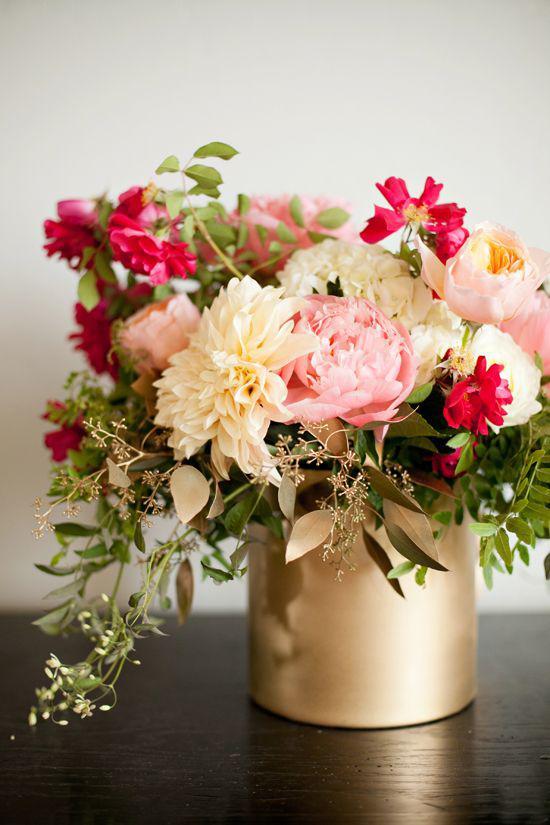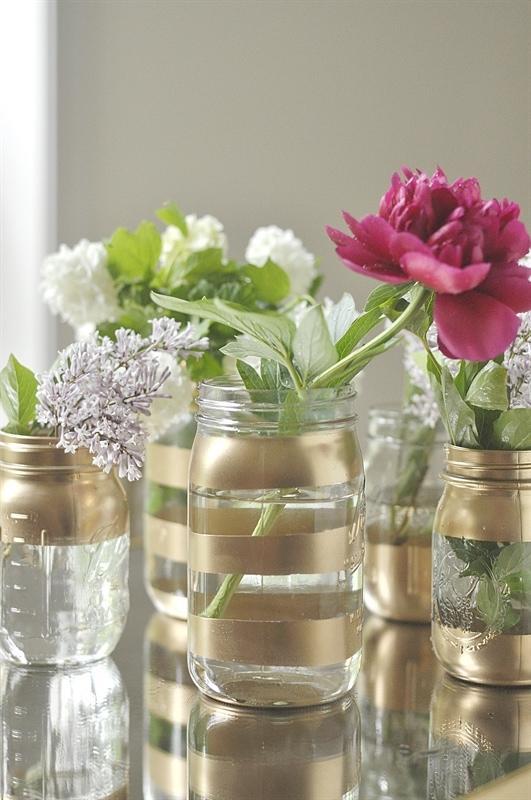The first image is the image on the left, the second image is the image on the right. Analyze the images presented: Is the assertion "There are more vases in the image on the left." valid? Answer yes or no. No. 